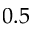<formula> <loc_0><loc_0><loc_500><loc_500>0 . 5</formula> 